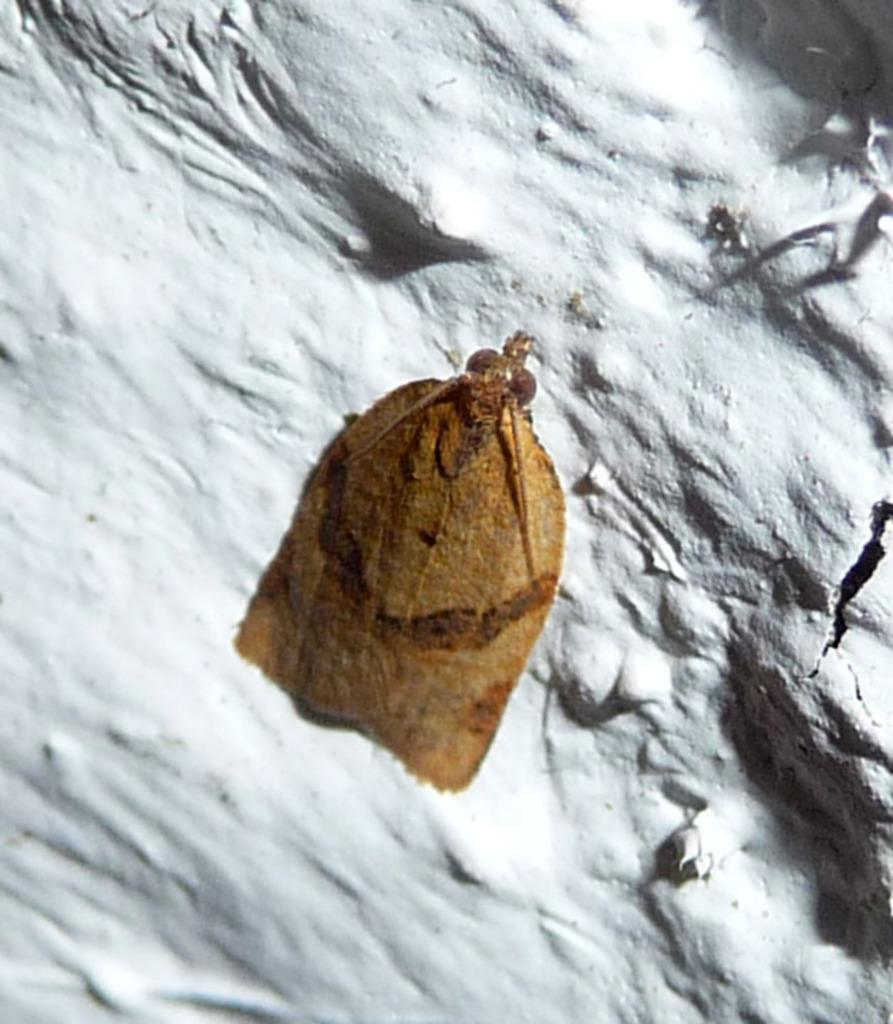What type of creature is present in the image? There is an insect in the image. What is the color of the insect? The insect is brown in color. What is the background or surface on which the insect is located? The insect is on a white surface. What is the purpose of the sheet in the image? There is no sheet present in the image. 